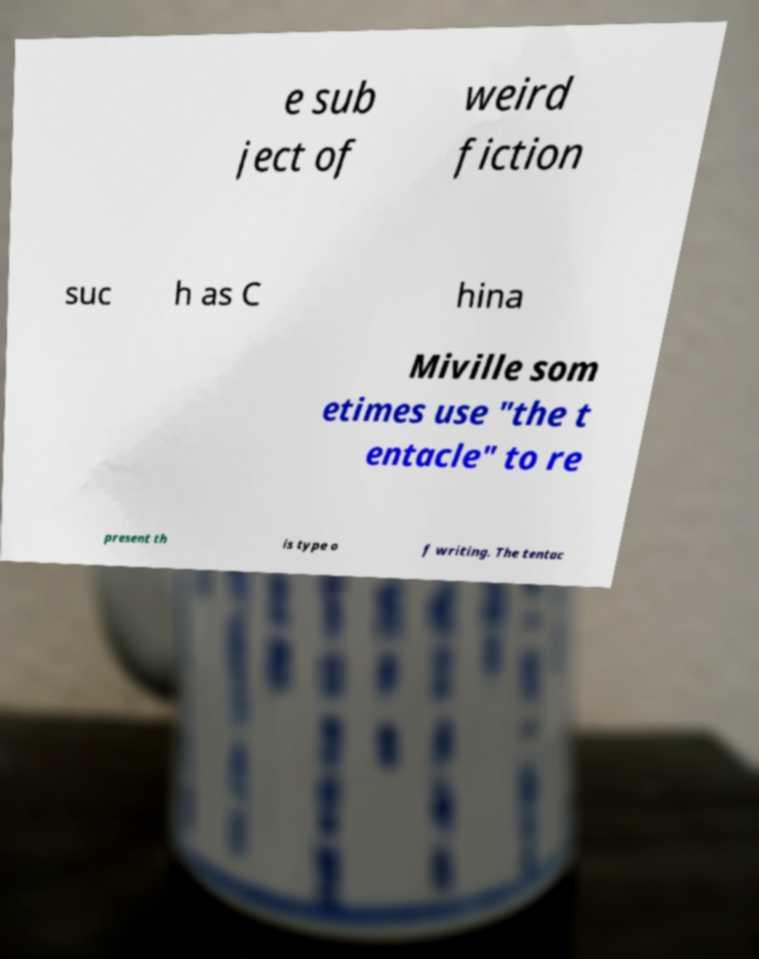Can you read and provide the text displayed in the image?This photo seems to have some interesting text. Can you extract and type it out for me? e sub ject of weird fiction suc h as C hina Miville som etimes use "the t entacle" to re present th is type o f writing. The tentac 